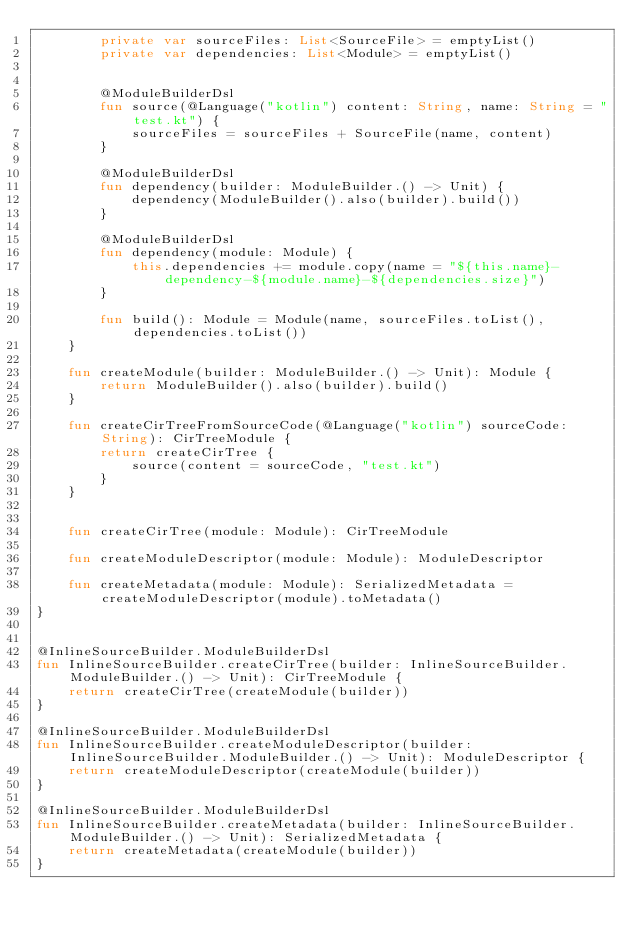<code> <loc_0><loc_0><loc_500><loc_500><_Kotlin_>        private var sourceFiles: List<SourceFile> = emptyList()
        private var dependencies: List<Module> = emptyList()


        @ModuleBuilderDsl
        fun source(@Language("kotlin") content: String, name: String = "test.kt") {
            sourceFiles = sourceFiles + SourceFile(name, content)
        }

        @ModuleBuilderDsl
        fun dependency(builder: ModuleBuilder.() -> Unit) {
            dependency(ModuleBuilder().also(builder).build())
        }

        @ModuleBuilderDsl
        fun dependency(module: Module) {
            this.dependencies += module.copy(name = "${this.name}-dependency-${module.name}-${dependencies.size}")
        }

        fun build(): Module = Module(name, sourceFiles.toList(), dependencies.toList())
    }

    fun createModule(builder: ModuleBuilder.() -> Unit): Module {
        return ModuleBuilder().also(builder).build()
    }

    fun createCirTreeFromSourceCode(@Language("kotlin") sourceCode: String): CirTreeModule {
        return createCirTree {
            source(content = sourceCode, "test.kt")
        }
    }


    fun createCirTree(module: Module): CirTreeModule

    fun createModuleDescriptor(module: Module): ModuleDescriptor

    fun createMetadata(module: Module): SerializedMetadata = createModuleDescriptor(module).toMetadata()
}


@InlineSourceBuilder.ModuleBuilderDsl
fun InlineSourceBuilder.createCirTree(builder: InlineSourceBuilder.ModuleBuilder.() -> Unit): CirTreeModule {
    return createCirTree(createModule(builder))
}

@InlineSourceBuilder.ModuleBuilderDsl
fun InlineSourceBuilder.createModuleDescriptor(builder: InlineSourceBuilder.ModuleBuilder.() -> Unit): ModuleDescriptor {
    return createModuleDescriptor(createModule(builder))
}

@InlineSourceBuilder.ModuleBuilderDsl
fun InlineSourceBuilder.createMetadata(builder: InlineSourceBuilder.ModuleBuilder.() -> Unit): SerializedMetadata {
    return createMetadata(createModule(builder))
}

</code> 